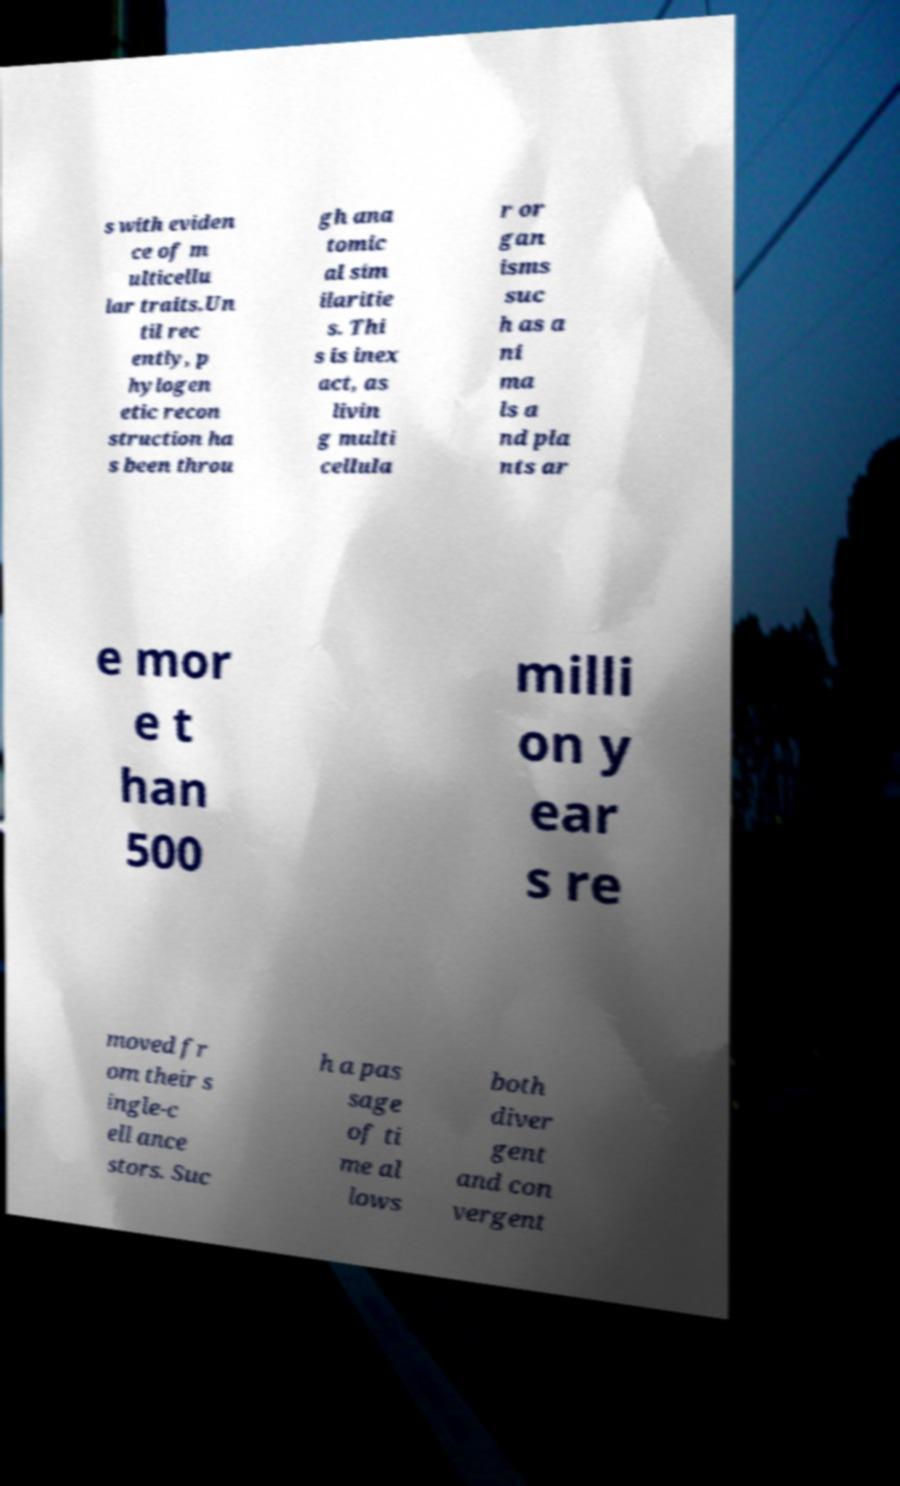Could you assist in decoding the text presented in this image and type it out clearly? s with eviden ce of m ulticellu lar traits.Un til rec ently, p hylogen etic recon struction ha s been throu gh ana tomic al sim ilaritie s. Thi s is inex act, as livin g multi cellula r or gan isms suc h as a ni ma ls a nd pla nts ar e mor e t han 500 milli on y ear s re moved fr om their s ingle-c ell ance stors. Suc h a pas sage of ti me al lows both diver gent and con vergent 